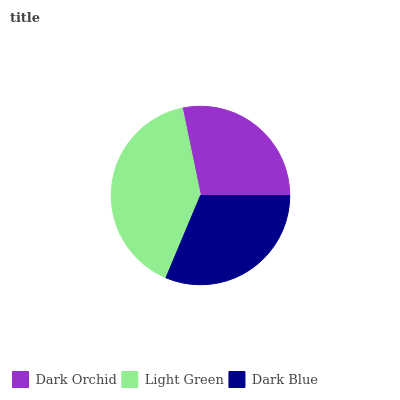Is Dark Orchid the minimum?
Answer yes or no. Yes. Is Light Green the maximum?
Answer yes or no. Yes. Is Dark Blue the minimum?
Answer yes or no. No. Is Dark Blue the maximum?
Answer yes or no. No. Is Light Green greater than Dark Blue?
Answer yes or no. Yes. Is Dark Blue less than Light Green?
Answer yes or no. Yes. Is Dark Blue greater than Light Green?
Answer yes or no. No. Is Light Green less than Dark Blue?
Answer yes or no. No. Is Dark Blue the high median?
Answer yes or no. Yes. Is Dark Blue the low median?
Answer yes or no. Yes. Is Dark Orchid the high median?
Answer yes or no. No. Is Dark Orchid the low median?
Answer yes or no. No. 